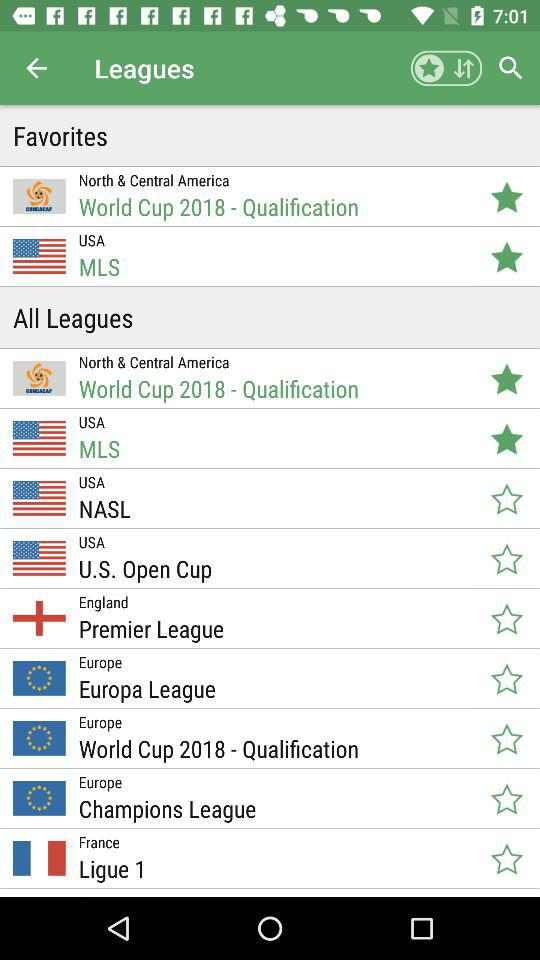Which leagues are selected as favorites? The leagues that are selected are "World Cup 2018 - Qualification" and "MLS". 